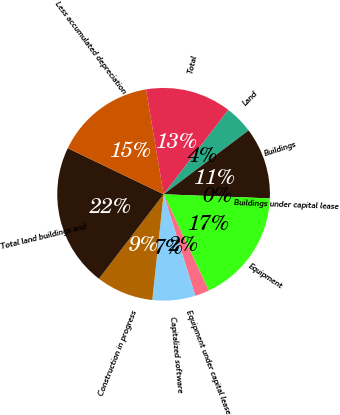Convert chart to OTSL. <chart><loc_0><loc_0><loc_500><loc_500><pie_chart><fcel>Land<fcel>Buildings<fcel>Buildings under capital lease<fcel>Equipment<fcel>Equipment under capital lease<fcel>Capitalized software<fcel>Construction in progress<fcel>Total land buildings and<fcel>Less accumulated depreciation<fcel>Total<nl><fcel>4.35%<fcel>10.87%<fcel>0.0%<fcel>17.39%<fcel>2.17%<fcel>6.52%<fcel>8.7%<fcel>21.74%<fcel>15.22%<fcel>13.04%<nl></chart> 